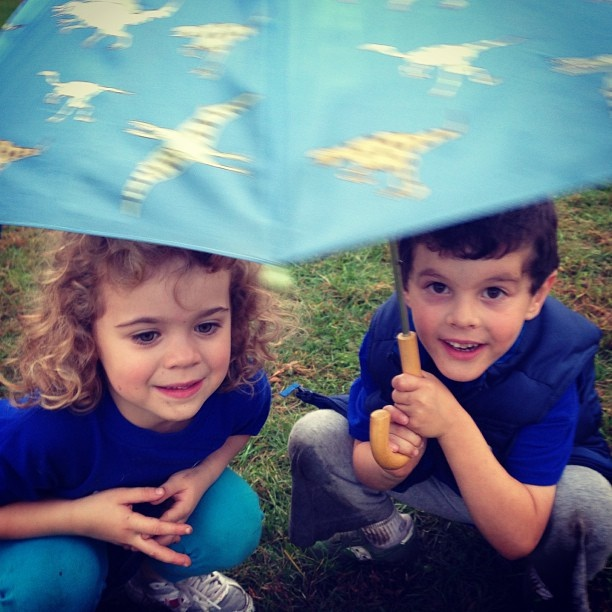Describe the objects in this image and their specific colors. I can see umbrella in darkgreen, lightblue, teal, and beige tones, people in darkgreen, navy, brown, and salmon tones, and people in darkgreen, navy, brown, and gray tones in this image. 